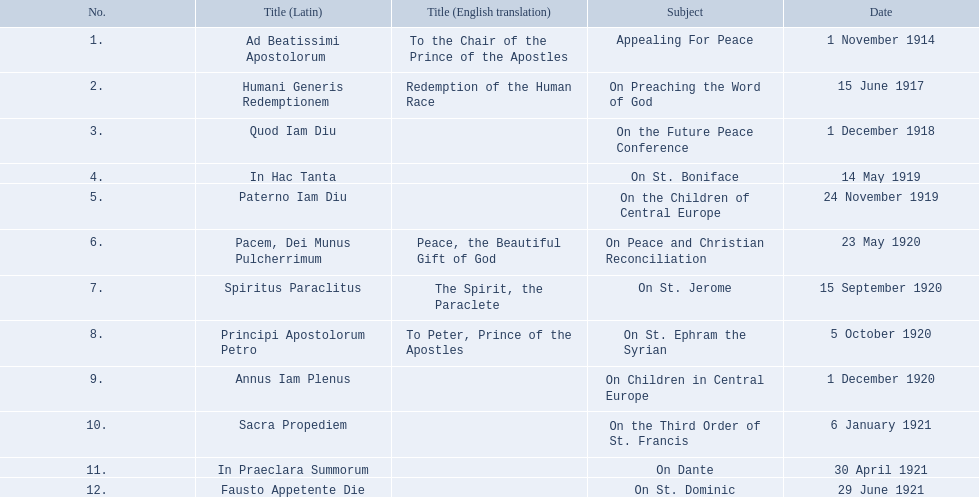What are all the disciplines? Appealing For Peace, On Preaching the Word of God, On the Future Peace Conference, On St. Boniface, On the Children of Central Europe, On Peace and Christian Reconciliation, On St. Jerome, On St. Ephram the Syrian, On Children in Central Europe, On the Third Order of St. Francis, On Dante, On St. Dominic. Which transpired in 1920? On Peace and Christian Reconciliation, On St. Jerome, On St. Ephram the Syrian, On Children in Central Europe. Which occurred in may during that year? On Peace and Christian Reconciliation. 